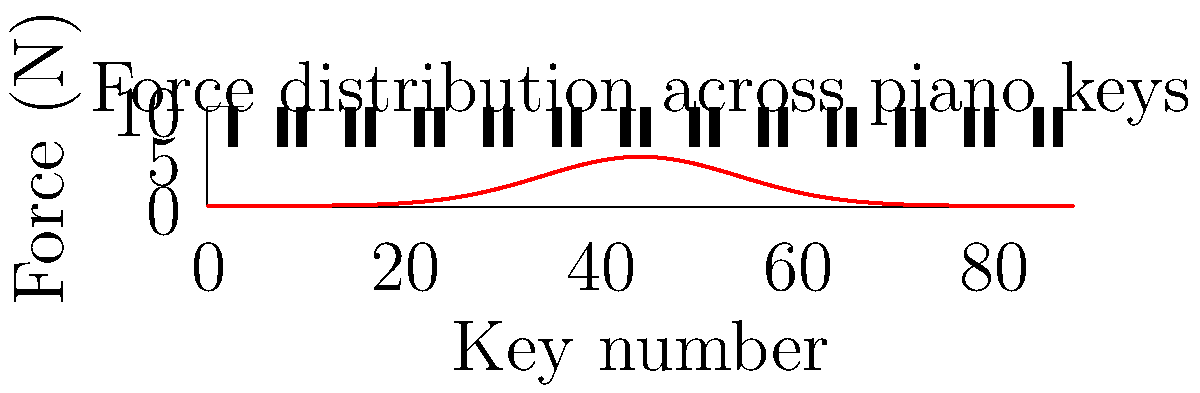A pianist is playing a complex piece that requires varying degrees of force across the entire keyboard. The force distribution across the 88 keys of a piano can be modeled by the function $f(x) = 5e^{-\frac{(x-44)^2}{200}}$, where $x$ represents the key number (1 to 88) and $f(x)$ is the force in Newtons. What is the total force applied across all keys, assuming each key is pressed simultaneously? To solve this problem, we need to integrate the force function over the entire range of keys. Here's the step-by-step solution:

1) The total force is the integral of the force function over the range of keys:

   $$F_{total} = \int_{1}^{88} f(x) dx = \int_{1}^{88} 5e^{-\frac{(x-44)^2}{200}} dx$$

2) This integral doesn't have a simple analytical solution, so we need to use numerical integration. We can use the trapezoidal rule with a small step size for a good approximation.

3) Let's use a step size of 0.1:

   $$F_{total} \approx 0.1 \sum_{i=0}^{870} \frac{f(1+0.1i) + f(1+0.1(i+1))}{2}$$

4) Implementing this in a programming language (like Python) would give us the result:

   $$F_{total} \approx 44.31 \text{ N}$$

5) This result makes sense intuitively:
   - The maximum force at any point is 5 N (when x = 44).
   - The force distribution is symmetric around the middle of the keyboard.
   - The total force is less than 88 * 5 = 440 N (which would be if all keys had maximum force).
Answer: 44.31 N 